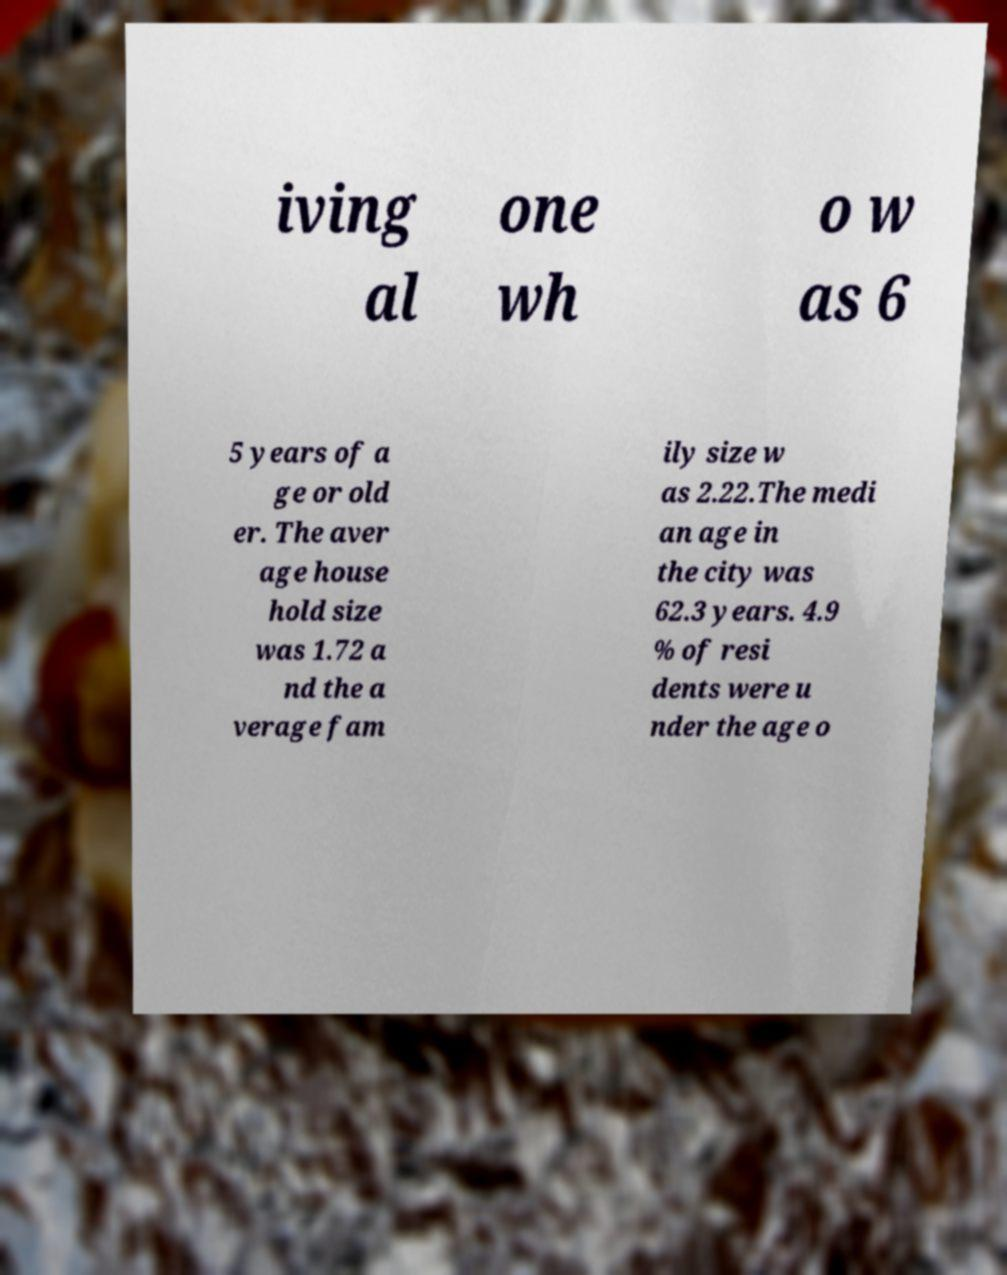Please read and relay the text visible in this image. What does it say? iving al one wh o w as 6 5 years of a ge or old er. The aver age house hold size was 1.72 a nd the a verage fam ily size w as 2.22.The medi an age in the city was 62.3 years. 4.9 % of resi dents were u nder the age o 